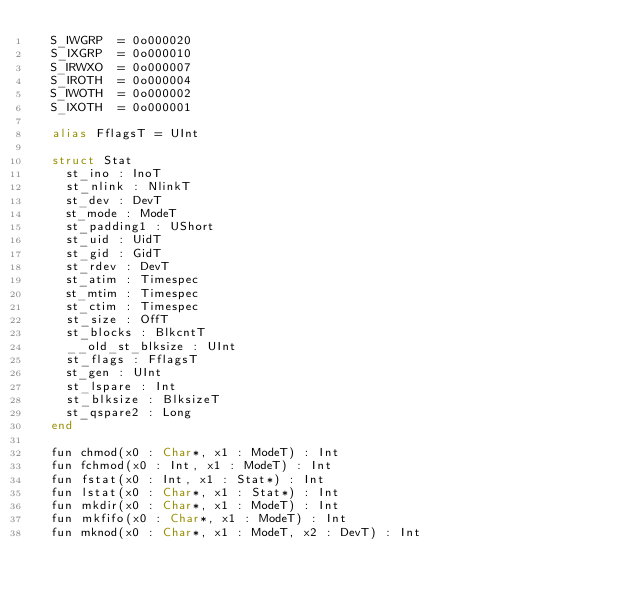<code> <loc_0><loc_0><loc_500><loc_500><_Crystal_>  S_IWGRP  = 0o000020
  S_IXGRP  = 0o000010
  S_IRWXO  = 0o000007
  S_IROTH  = 0o000004
  S_IWOTH  = 0o000002
  S_IXOTH  = 0o000001

  alias FflagsT = UInt

  struct Stat
    st_ino : InoT
    st_nlink : NlinkT
    st_dev : DevT
    st_mode : ModeT
    st_padding1 : UShort
    st_uid : UidT
    st_gid : GidT
    st_rdev : DevT
    st_atim : Timespec
    st_mtim : Timespec
    st_ctim : Timespec
    st_size : OffT
    st_blocks : BlkcntT
    __old_st_blksize : UInt
    st_flags : FflagsT
    st_gen : UInt
    st_lspare : Int
    st_blksize : BlksizeT
    st_qspare2 : Long
  end

  fun chmod(x0 : Char*, x1 : ModeT) : Int
  fun fchmod(x0 : Int, x1 : ModeT) : Int
  fun fstat(x0 : Int, x1 : Stat*) : Int
  fun lstat(x0 : Char*, x1 : Stat*) : Int
  fun mkdir(x0 : Char*, x1 : ModeT) : Int
  fun mkfifo(x0 : Char*, x1 : ModeT) : Int
  fun mknod(x0 : Char*, x1 : ModeT, x2 : DevT) : Int</code> 